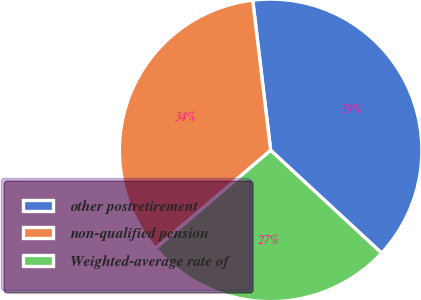<chart> <loc_0><loc_0><loc_500><loc_500><pie_chart><fcel>other postretirement<fcel>non-qualified pension<fcel>Weighted-average rate of<nl><fcel>38.78%<fcel>34.33%<fcel>26.89%<nl></chart> 